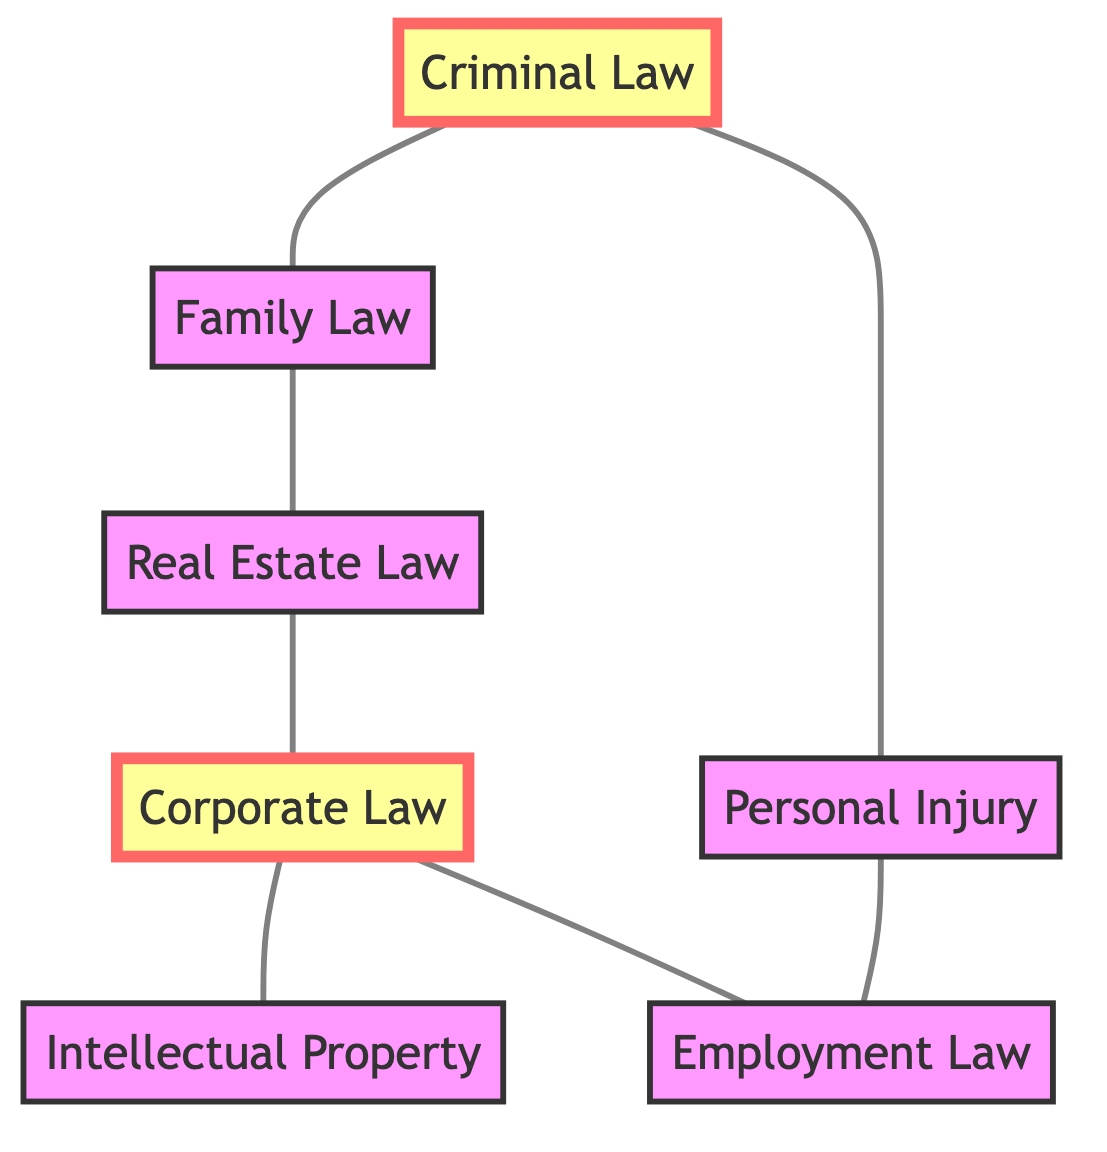What are the different types of law represented in the graph? The graph contains the following types of law: Corporate Law, Criminal Law, Family Law, Intellectual Property, Employment Law, Personal Injury, and Real Estate Law. These are the nodes in the diagram.
Answer: Corporate Law, Criminal Law, Family Law, Intellectual Property, Employment Law, Personal Injury, Real Estate Law How many edges are present in the graph? Each edge represents a connection between two nodes. Counting the edges listed, there are a total of 7 connections: Corporate Law to Intellectual Property, Corporate Law to Employment Law, Criminal Law to Family Law, Criminal Law to Personal Injury, Family Law to Real Estate Law, Personal Injury to Employment Law, and Real Estate Law to Corporate Law.
Answer: 7 Which two areas of law are connected to Corporate Law? The edges connected to Corporate Law are to Intellectual Property and Employment Law. By inspecting these connections, we can determine the related areas.
Answer: Intellectual Property, Employment Law Is there a direct connection between Criminal Law and Real Estate Law? By examining the connections (edges) displayed in the graph, Criminal Law does not have any direct edge connecting it to Real Estate Law. The edges only connect Criminal Law to Family Law and Personal Injury.
Answer: No What is the relationship between Family Law and Real Estate Law? The edge connecting Family Law to Real Estate Law indicates a direct relationship between these two areas of law. They are directly connected and show a relationship in the graph.
Answer: They are directly connected How many nodes are highlighted in the diagram? There are two nodes highlighted in the diagram: Corporate Law and Criminal Law. The highlighting indicates these nodes are important or of interest.
Answer: 2 Which areas of law are directly connected to Personal Injury? Personal Injury has direct connections to other law areas which can be traced through the edges: it connects to Employment Law and Criminal Law.
Answer: Criminal Law, Employment Law What is the connection between Corporate Law and Real Estate Law? There is an edge connecting Corporate Law to Real Estate Law in the diagram, which indicates a direct relationship between these two areas through one intermediate connection.
Answer: They are directly connected 